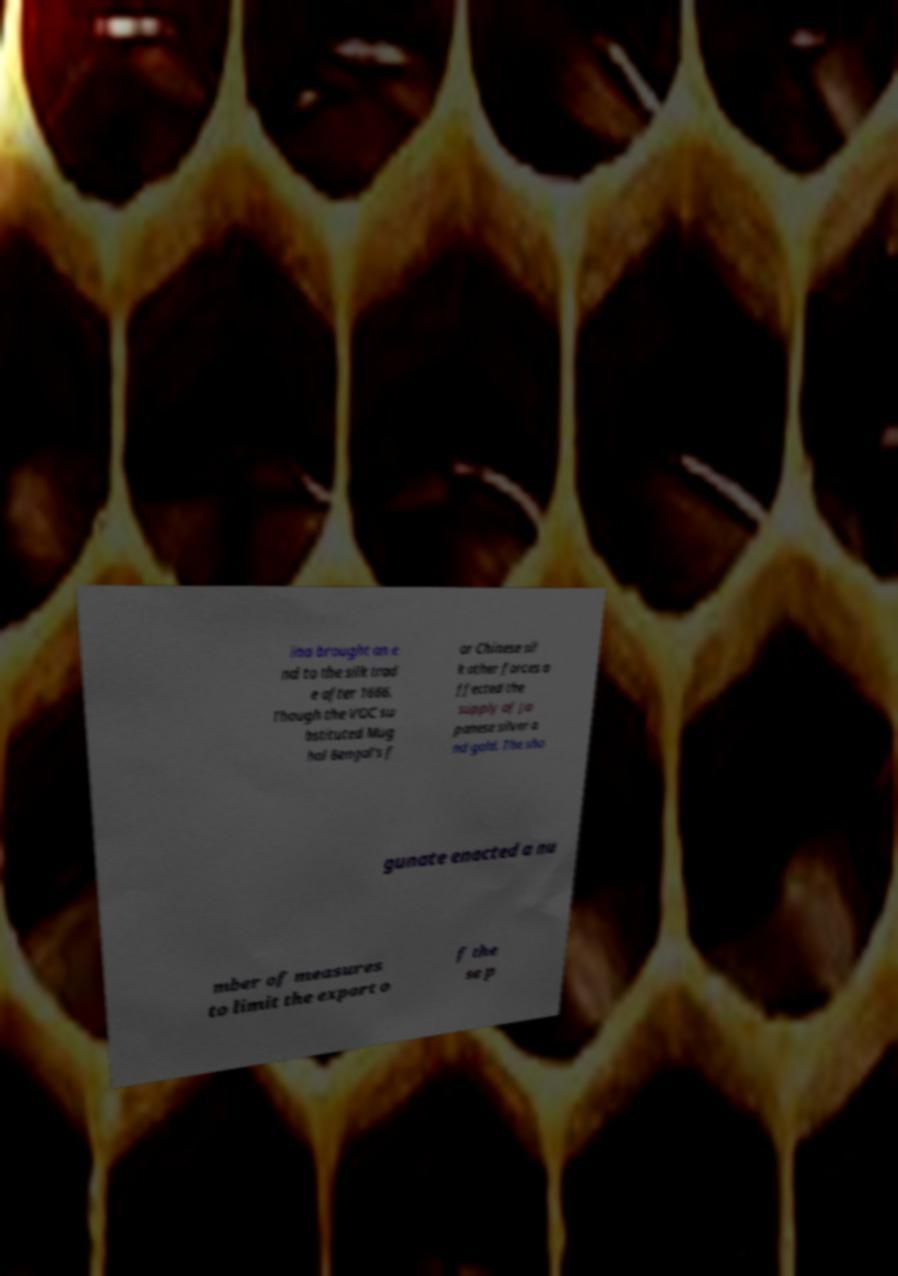Could you extract and type out the text from this image? ina brought an e nd to the silk trad e after 1666. Though the VOC su bstituted Mug hal Bengal's f or Chinese sil k other forces a ffected the supply of Ja panese silver a nd gold. The sho gunate enacted a nu mber of measures to limit the export o f the se p 